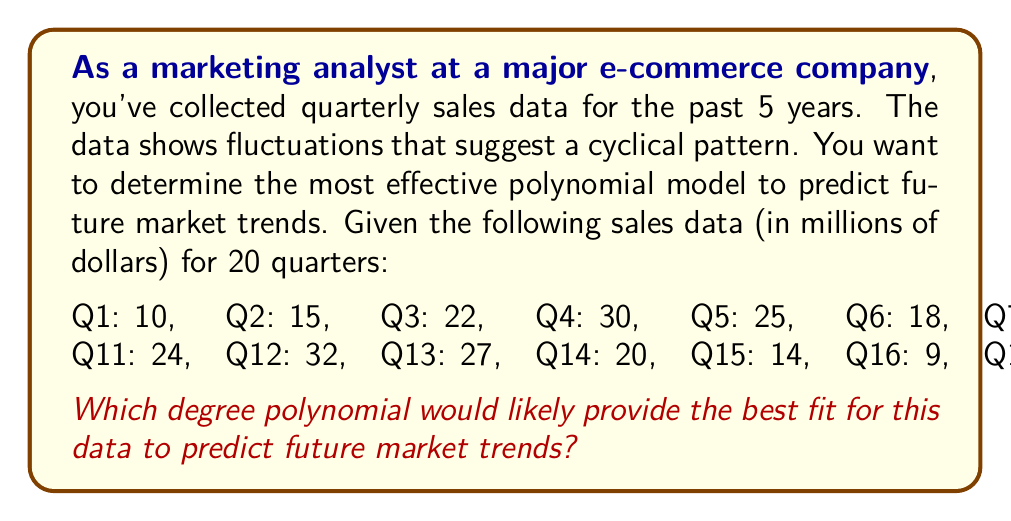Provide a solution to this math problem. To determine the most effective polynomial model for predicting market trends, we need to analyze the pattern in the given data. Let's approach this step-by-step:

1. Observe the pattern:
   The data shows a repeating cycle that appears to complete roughly every 8 quarters (2 years).

2. Consider the shape:
   Within each cycle, the pattern rises to a peak and then falls, resembling a sinusoidal wave.

3. Polynomial degree analysis:
   - A linear polynomial (degree 1) would only capture an overall increasing or decreasing trend, which is insufficient for this cyclical data.
   - A quadratic polynomial (degree 2) could capture a single rise and fall, but not multiple cycles.
   - A cubic polynomial (degree 3) might capture more complexity but still wouldn't adequately represent multiple cycles.
   - Higher degree polynomials (4 and above) can approximate more complex patterns.

4. Minimum degree estimation:
   To capture a cyclical pattern that repeats approximately every 8 data points, we need a polynomial that can change direction multiple times. As a rule of thumb, the degree of the polynomial should be at least one less than the number of direction changes in the data.

5. Optimal degree:
   Given that we have 20 data points with about 2.5 cycles, we would need a polynomial of at least degree 7 to capture the essence of this pattern (2.5 cycles * 3 direction changes per cycle - 1 = 6.5, rounded up to 7).

6. Overfitting consideration:
   While higher degree polynomials (e.g., degree 19) could fit the given data points almost perfectly, they would likely overfit and perform poorly for prediction.

7. Final recommendation:
   A 7th or 8th degree polynomial would likely provide the best balance between fitting the observed pattern and avoiding overfitting, making it the most effective for predicting future market trends in this scenario.
Answer: 7th or 8th degree polynomial 